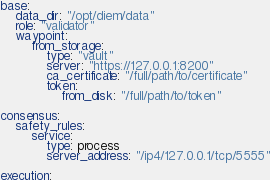Convert code to text. <code><loc_0><loc_0><loc_500><loc_500><_YAML_>base:
    data_dir: "/opt/diem/data"
    role: "validator"
    waypoint:
        from_storage:
            type: "vault"
            server: "https://127.0.0.1:8200"
            ca_certificate: "/full/path/to/certificate"
            token:
                from_disk: "/full/path/to/token"

consensus:
    safety_rules:
        service:
            type: process
            server_address: "/ip4/127.0.0.1/tcp/5555"

execution:</code> 